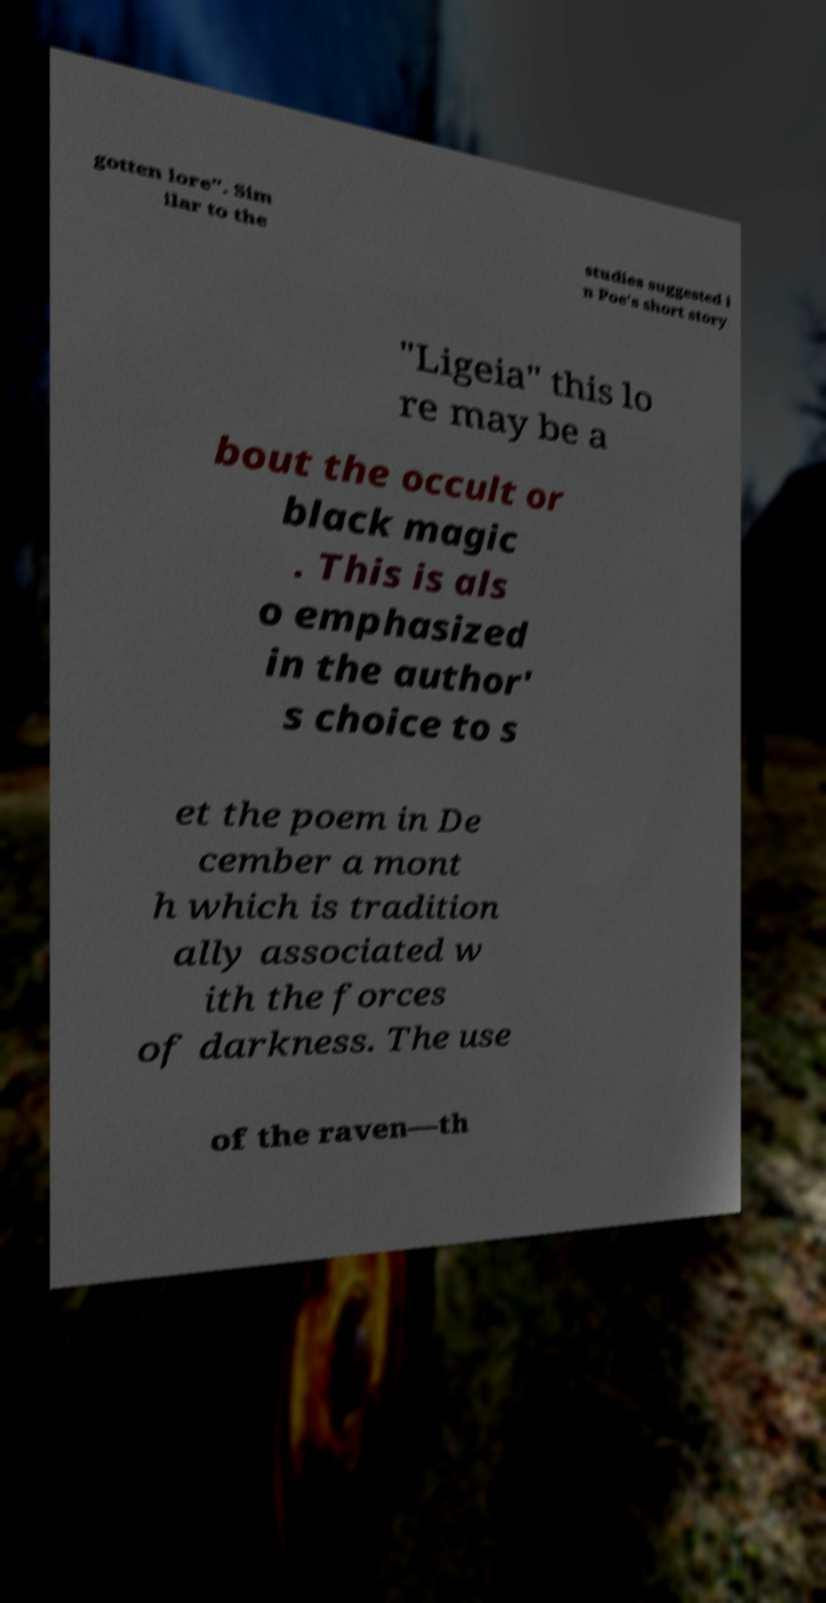There's text embedded in this image that I need extracted. Can you transcribe it verbatim? gotten lore". Sim ilar to the studies suggested i n Poe's short story "Ligeia" this lo re may be a bout the occult or black magic . This is als o emphasized in the author' s choice to s et the poem in De cember a mont h which is tradition ally associated w ith the forces of darkness. The use of the raven—th 